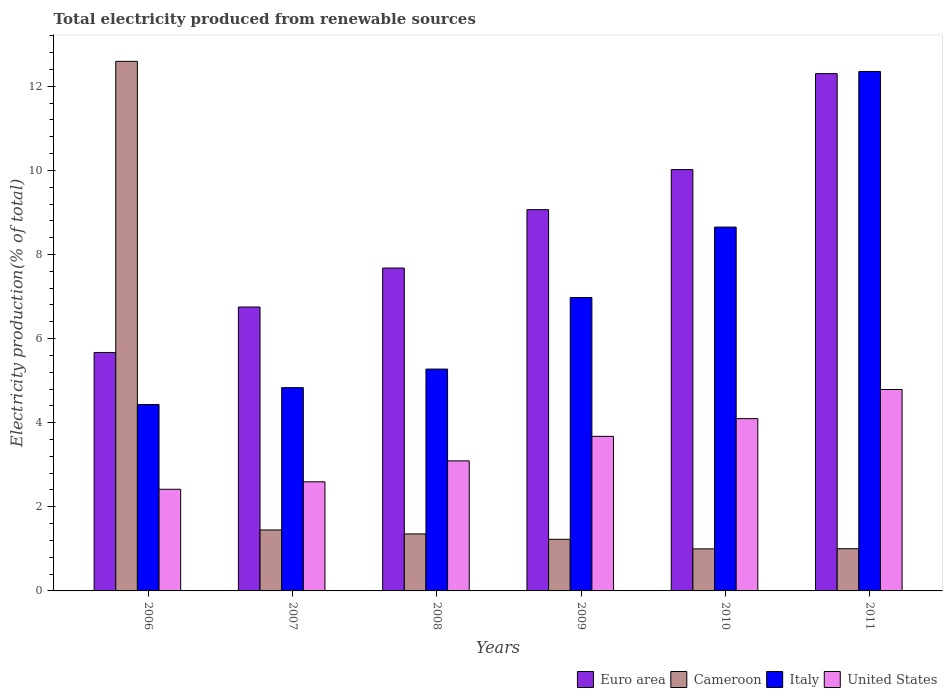How many different coloured bars are there?
Keep it short and to the point. 4. How many bars are there on the 1st tick from the left?
Give a very brief answer. 4. How many bars are there on the 3rd tick from the right?
Give a very brief answer. 4. What is the label of the 4th group of bars from the left?
Your answer should be compact. 2009. What is the total electricity produced in Cameroon in 2006?
Give a very brief answer. 12.59. Across all years, what is the maximum total electricity produced in Italy?
Provide a short and direct response. 12.35. Across all years, what is the minimum total electricity produced in Euro area?
Give a very brief answer. 5.67. What is the total total electricity produced in Cameroon in the graph?
Your answer should be very brief. 18.63. What is the difference between the total electricity produced in Cameroon in 2009 and that in 2011?
Make the answer very short. 0.22. What is the difference between the total electricity produced in Italy in 2009 and the total electricity produced in Cameroon in 2006?
Your answer should be very brief. -5.62. What is the average total electricity produced in United States per year?
Your response must be concise. 3.44. In the year 2009, what is the difference between the total electricity produced in Italy and total electricity produced in Cameroon?
Give a very brief answer. 5.75. In how many years, is the total electricity produced in Euro area greater than 2.4 %?
Provide a succinct answer. 6. What is the ratio of the total electricity produced in Italy in 2007 to that in 2008?
Offer a very short reply. 0.92. Is the total electricity produced in Euro area in 2007 less than that in 2011?
Keep it short and to the point. Yes. Is the difference between the total electricity produced in Italy in 2006 and 2010 greater than the difference between the total electricity produced in Cameroon in 2006 and 2010?
Your answer should be compact. No. What is the difference between the highest and the second highest total electricity produced in Italy?
Ensure brevity in your answer.  3.7. What is the difference between the highest and the lowest total electricity produced in Euro area?
Make the answer very short. 6.63. In how many years, is the total electricity produced in United States greater than the average total electricity produced in United States taken over all years?
Your answer should be very brief. 3. Is the sum of the total electricity produced in Cameroon in 2009 and 2010 greater than the maximum total electricity produced in Euro area across all years?
Your answer should be compact. No. Is it the case that in every year, the sum of the total electricity produced in Cameroon and total electricity produced in Italy is greater than the sum of total electricity produced in United States and total electricity produced in Euro area?
Your answer should be compact. No. What does the 2nd bar from the left in 2009 represents?
Provide a succinct answer. Cameroon. Is it the case that in every year, the sum of the total electricity produced in Euro area and total electricity produced in United States is greater than the total electricity produced in Italy?
Keep it short and to the point. Yes. How many bars are there?
Your answer should be very brief. 24. Are all the bars in the graph horizontal?
Make the answer very short. No. How many years are there in the graph?
Your response must be concise. 6. How are the legend labels stacked?
Give a very brief answer. Horizontal. What is the title of the graph?
Provide a succinct answer. Total electricity produced from renewable sources. What is the Electricity production(% of total) in Euro area in 2006?
Ensure brevity in your answer.  5.67. What is the Electricity production(% of total) of Cameroon in 2006?
Provide a short and direct response. 12.59. What is the Electricity production(% of total) of Italy in 2006?
Your answer should be compact. 4.43. What is the Electricity production(% of total) of United States in 2006?
Provide a succinct answer. 2.42. What is the Electricity production(% of total) of Euro area in 2007?
Give a very brief answer. 6.75. What is the Electricity production(% of total) of Cameroon in 2007?
Provide a succinct answer. 1.45. What is the Electricity production(% of total) in Italy in 2007?
Your answer should be very brief. 4.83. What is the Electricity production(% of total) of United States in 2007?
Give a very brief answer. 2.59. What is the Electricity production(% of total) in Euro area in 2008?
Give a very brief answer. 7.68. What is the Electricity production(% of total) in Cameroon in 2008?
Give a very brief answer. 1.36. What is the Electricity production(% of total) in Italy in 2008?
Keep it short and to the point. 5.28. What is the Electricity production(% of total) of United States in 2008?
Your answer should be compact. 3.09. What is the Electricity production(% of total) of Euro area in 2009?
Offer a terse response. 9.07. What is the Electricity production(% of total) of Cameroon in 2009?
Offer a terse response. 1.23. What is the Electricity production(% of total) of Italy in 2009?
Your answer should be compact. 6.98. What is the Electricity production(% of total) in United States in 2009?
Your response must be concise. 3.68. What is the Electricity production(% of total) in Euro area in 2010?
Your answer should be compact. 10.02. What is the Electricity production(% of total) in Cameroon in 2010?
Provide a succinct answer. 1. What is the Electricity production(% of total) of Italy in 2010?
Make the answer very short. 8.65. What is the Electricity production(% of total) of United States in 2010?
Give a very brief answer. 4.1. What is the Electricity production(% of total) in Euro area in 2011?
Make the answer very short. 12.3. What is the Electricity production(% of total) of Cameroon in 2011?
Provide a succinct answer. 1. What is the Electricity production(% of total) of Italy in 2011?
Keep it short and to the point. 12.35. What is the Electricity production(% of total) in United States in 2011?
Provide a short and direct response. 4.79. Across all years, what is the maximum Electricity production(% of total) in Euro area?
Provide a succinct answer. 12.3. Across all years, what is the maximum Electricity production(% of total) in Cameroon?
Offer a very short reply. 12.59. Across all years, what is the maximum Electricity production(% of total) in Italy?
Give a very brief answer. 12.35. Across all years, what is the maximum Electricity production(% of total) in United States?
Your answer should be very brief. 4.79. Across all years, what is the minimum Electricity production(% of total) of Euro area?
Offer a terse response. 5.67. Across all years, what is the minimum Electricity production(% of total) in Cameroon?
Offer a very short reply. 1. Across all years, what is the minimum Electricity production(% of total) in Italy?
Your answer should be compact. 4.43. Across all years, what is the minimum Electricity production(% of total) in United States?
Make the answer very short. 2.42. What is the total Electricity production(% of total) in Euro area in the graph?
Give a very brief answer. 51.49. What is the total Electricity production(% of total) of Cameroon in the graph?
Give a very brief answer. 18.63. What is the total Electricity production(% of total) in Italy in the graph?
Provide a short and direct response. 42.52. What is the total Electricity production(% of total) of United States in the graph?
Provide a short and direct response. 20.67. What is the difference between the Electricity production(% of total) of Euro area in 2006 and that in 2007?
Offer a terse response. -1.08. What is the difference between the Electricity production(% of total) in Cameroon in 2006 and that in 2007?
Your answer should be compact. 11.14. What is the difference between the Electricity production(% of total) of Italy in 2006 and that in 2007?
Ensure brevity in your answer.  -0.4. What is the difference between the Electricity production(% of total) of United States in 2006 and that in 2007?
Make the answer very short. -0.18. What is the difference between the Electricity production(% of total) of Euro area in 2006 and that in 2008?
Keep it short and to the point. -2.01. What is the difference between the Electricity production(% of total) of Cameroon in 2006 and that in 2008?
Ensure brevity in your answer.  11.24. What is the difference between the Electricity production(% of total) in Italy in 2006 and that in 2008?
Your response must be concise. -0.84. What is the difference between the Electricity production(% of total) of United States in 2006 and that in 2008?
Your answer should be compact. -0.68. What is the difference between the Electricity production(% of total) of Euro area in 2006 and that in 2009?
Your answer should be compact. -3.4. What is the difference between the Electricity production(% of total) of Cameroon in 2006 and that in 2009?
Your response must be concise. 11.37. What is the difference between the Electricity production(% of total) in Italy in 2006 and that in 2009?
Offer a terse response. -2.54. What is the difference between the Electricity production(% of total) of United States in 2006 and that in 2009?
Provide a short and direct response. -1.26. What is the difference between the Electricity production(% of total) in Euro area in 2006 and that in 2010?
Your answer should be compact. -4.35. What is the difference between the Electricity production(% of total) of Cameroon in 2006 and that in 2010?
Make the answer very short. 11.59. What is the difference between the Electricity production(% of total) in Italy in 2006 and that in 2010?
Provide a short and direct response. -4.22. What is the difference between the Electricity production(% of total) in United States in 2006 and that in 2010?
Ensure brevity in your answer.  -1.68. What is the difference between the Electricity production(% of total) of Euro area in 2006 and that in 2011?
Offer a terse response. -6.63. What is the difference between the Electricity production(% of total) in Cameroon in 2006 and that in 2011?
Give a very brief answer. 11.59. What is the difference between the Electricity production(% of total) of Italy in 2006 and that in 2011?
Ensure brevity in your answer.  -7.92. What is the difference between the Electricity production(% of total) in United States in 2006 and that in 2011?
Provide a short and direct response. -2.37. What is the difference between the Electricity production(% of total) in Euro area in 2007 and that in 2008?
Ensure brevity in your answer.  -0.93. What is the difference between the Electricity production(% of total) of Cameroon in 2007 and that in 2008?
Ensure brevity in your answer.  0.09. What is the difference between the Electricity production(% of total) in Italy in 2007 and that in 2008?
Your response must be concise. -0.44. What is the difference between the Electricity production(% of total) of United States in 2007 and that in 2008?
Your answer should be very brief. -0.5. What is the difference between the Electricity production(% of total) in Euro area in 2007 and that in 2009?
Provide a succinct answer. -2.32. What is the difference between the Electricity production(% of total) in Cameroon in 2007 and that in 2009?
Offer a terse response. 0.22. What is the difference between the Electricity production(% of total) in Italy in 2007 and that in 2009?
Offer a very short reply. -2.14. What is the difference between the Electricity production(% of total) in United States in 2007 and that in 2009?
Provide a short and direct response. -1.08. What is the difference between the Electricity production(% of total) of Euro area in 2007 and that in 2010?
Provide a succinct answer. -3.27. What is the difference between the Electricity production(% of total) in Cameroon in 2007 and that in 2010?
Your answer should be compact. 0.45. What is the difference between the Electricity production(% of total) of Italy in 2007 and that in 2010?
Your response must be concise. -3.82. What is the difference between the Electricity production(% of total) in United States in 2007 and that in 2010?
Give a very brief answer. -1.5. What is the difference between the Electricity production(% of total) in Euro area in 2007 and that in 2011?
Your response must be concise. -5.55. What is the difference between the Electricity production(% of total) in Cameroon in 2007 and that in 2011?
Ensure brevity in your answer.  0.45. What is the difference between the Electricity production(% of total) of Italy in 2007 and that in 2011?
Your answer should be compact. -7.52. What is the difference between the Electricity production(% of total) of United States in 2007 and that in 2011?
Your answer should be very brief. -2.19. What is the difference between the Electricity production(% of total) of Euro area in 2008 and that in 2009?
Ensure brevity in your answer.  -1.39. What is the difference between the Electricity production(% of total) of Cameroon in 2008 and that in 2009?
Provide a succinct answer. 0.13. What is the difference between the Electricity production(% of total) in Italy in 2008 and that in 2009?
Your answer should be compact. -1.7. What is the difference between the Electricity production(% of total) in United States in 2008 and that in 2009?
Offer a terse response. -0.58. What is the difference between the Electricity production(% of total) in Euro area in 2008 and that in 2010?
Your answer should be very brief. -2.34. What is the difference between the Electricity production(% of total) in Cameroon in 2008 and that in 2010?
Your answer should be compact. 0.36. What is the difference between the Electricity production(% of total) of Italy in 2008 and that in 2010?
Provide a short and direct response. -3.38. What is the difference between the Electricity production(% of total) in United States in 2008 and that in 2010?
Your answer should be compact. -1. What is the difference between the Electricity production(% of total) in Euro area in 2008 and that in 2011?
Offer a very short reply. -4.62. What is the difference between the Electricity production(% of total) in Cameroon in 2008 and that in 2011?
Provide a succinct answer. 0.35. What is the difference between the Electricity production(% of total) of Italy in 2008 and that in 2011?
Your answer should be compact. -7.08. What is the difference between the Electricity production(% of total) of United States in 2008 and that in 2011?
Provide a succinct answer. -1.7. What is the difference between the Electricity production(% of total) of Euro area in 2009 and that in 2010?
Provide a succinct answer. -0.95. What is the difference between the Electricity production(% of total) in Cameroon in 2009 and that in 2010?
Offer a very short reply. 0.23. What is the difference between the Electricity production(% of total) in Italy in 2009 and that in 2010?
Offer a very short reply. -1.67. What is the difference between the Electricity production(% of total) of United States in 2009 and that in 2010?
Your answer should be compact. -0.42. What is the difference between the Electricity production(% of total) of Euro area in 2009 and that in 2011?
Offer a terse response. -3.23. What is the difference between the Electricity production(% of total) of Cameroon in 2009 and that in 2011?
Ensure brevity in your answer.  0.22. What is the difference between the Electricity production(% of total) in Italy in 2009 and that in 2011?
Offer a very short reply. -5.38. What is the difference between the Electricity production(% of total) in United States in 2009 and that in 2011?
Provide a short and direct response. -1.11. What is the difference between the Electricity production(% of total) of Euro area in 2010 and that in 2011?
Keep it short and to the point. -2.28. What is the difference between the Electricity production(% of total) in Cameroon in 2010 and that in 2011?
Your answer should be very brief. -0. What is the difference between the Electricity production(% of total) in Italy in 2010 and that in 2011?
Provide a short and direct response. -3.7. What is the difference between the Electricity production(% of total) in United States in 2010 and that in 2011?
Provide a short and direct response. -0.69. What is the difference between the Electricity production(% of total) in Euro area in 2006 and the Electricity production(% of total) in Cameroon in 2007?
Your response must be concise. 4.22. What is the difference between the Electricity production(% of total) in Euro area in 2006 and the Electricity production(% of total) in Italy in 2007?
Make the answer very short. 0.84. What is the difference between the Electricity production(% of total) in Euro area in 2006 and the Electricity production(% of total) in United States in 2007?
Offer a terse response. 3.08. What is the difference between the Electricity production(% of total) of Cameroon in 2006 and the Electricity production(% of total) of Italy in 2007?
Provide a succinct answer. 7.76. What is the difference between the Electricity production(% of total) in Cameroon in 2006 and the Electricity production(% of total) in United States in 2007?
Your answer should be very brief. 10. What is the difference between the Electricity production(% of total) in Italy in 2006 and the Electricity production(% of total) in United States in 2007?
Ensure brevity in your answer.  1.84. What is the difference between the Electricity production(% of total) of Euro area in 2006 and the Electricity production(% of total) of Cameroon in 2008?
Your answer should be compact. 4.31. What is the difference between the Electricity production(% of total) in Euro area in 2006 and the Electricity production(% of total) in Italy in 2008?
Provide a short and direct response. 0.39. What is the difference between the Electricity production(% of total) of Euro area in 2006 and the Electricity production(% of total) of United States in 2008?
Offer a very short reply. 2.58. What is the difference between the Electricity production(% of total) in Cameroon in 2006 and the Electricity production(% of total) in Italy in 2008?
Provide a succinct answer. 7.32. What is the difference between the Electricity production(% of total) in Cameroon in 2006 and the Electricity production(% of total) in United States in 2008?
Make the answer very short. 9.5. What is the difference between the Electricity production(% of total) of Italy in 2006 and the Electricity production(% of total) of United States in 2008?
Your answer should be compact. 1.34. What is the difference between the Electricity production(% of total) in Euro area in 2006 and the Electricity production(% of total) in Cameroon in 2009?
Offer a very short reply. 4.44. What is the difference between the Electricity production(% of total) in Euro area in 2006 and the Electricity production(% of total) in Italy in 2009?
Keep it short and to the point. -1.31. What is the difference between the Electricity production(% of total) in Euro area in 2006 and the Electricity production(% of total) in United States in 2009?
Offer a very short reply. 1.99. What is the difference between the Electricity production(% of total) in Cameroon in 2006 and the Electricity production(% of total) in Italy in 2009?
Ensure brevity in your answer.  5.62. What is the difference between the Electricity production(% of total) of Cameroon in 2006 and the Electricity production(% of total) of United States in 2009?
Offer a very short reply. 8.92. What is the difference between the Electricity production(% of total) in Italy in 2006 and the Electricity production(% of total) in United States in 2009?
Give a very brief answer. 0.76. What is the difference between the Electricity production(% of total) in Euro area in 2006 and the Electricity production(% of total) in Cameroon in 2010?
Make the answer very short. 4.67. What is the difference between the Electricity production(% of total) in Euro area in 2006 and the Electricity production(% of total) in Italy in 2010?
Offer a very short reply. -2.98. What is the difference between the Electricity production(% of total) of Euro area in 2006 and the Electricity production(% of total) of United States in 2010?
Provide a short and direct response. 1.57. What is the difference between the Electricity production(% of total) of Cameroon in 2006 and the Electricity production(% of total) of Italy in 2010?
Offer a very short reply. 3.94. What is the difference between the Electricity production(% of total) in Cameroon in 2006 and the Electricity production(% of total) in United States in 2010?
Your answer should be compact. 8.5. What is the difference between the Electricity production(% of total) of Italy in 2006 and the Electricity production(% of total) of United States in 2010?
Your answer should be very brief. 0.34. What is the difference between the Electricity production(% of total) of Euro area in 2006 and the Electricity production(% of total) of Cameroon in 2011?
Offer a very short reply. 4.67. What is the difference between the Electricity production(% of total) in Euro area in 2006 and the Electricity production(% of total) in Italy in 2011?
Make the answer very short. -6.68. What is the difference between the Electricity production(% of total) of Euro area in 2006 and the Electricity production(% of total) of United States in 2011?
Provide a succinct answer. 0.88. What is the difference between the Electricity production(% of total) of Cameroon in 2006 and the Electricity production(% of total) of Italy in 2011?
Offer a very short reply. 0.24. What is the difference between the Electricity production(% of total) in Cameroon in 2006 and the Electricity production(% of total) in United States in 2011?
Offer a terse response. 7.8. What is the difference between the Electricity production(% of total) in Italy in 2006 and the Electricity production(% of total) in United States in 2011?
Ensure brevity in your answer.  -0.36. What is the difference between the Electricity production(% of total) in Euro area in 2007 and the Electricity production(% of total) in Cameroon in 2008?
Your response must be concise. 5.4. What is the difference between the Electricity production(% of total) in Euro area in 2007 and the Electricity production(% of total) in Italy in 2008?
Your response must be concise. 1.48. What is the difference between the Electricity production(% of total) in Euro area in 2007 and the Electricity production(% of total) in United States in 2008?
Offer a terse response. 3.66. What is the difference between the Electricity production(% of total) of Cameroon in 2007 and the Electricity production(% of total) of Italy in 2008?
Give a very brief answer. -3.83. What is the difference between the Electricity production(% of total) of Cameroon in 2007 and the Electricity production(% of total) of United States in 2008?
Offer a very short reply. -1.64. What is the difference between the Electricity production(% of total) of Italy in 2007 and the Electricity production(% of total) of United States in 2008?
Your response must be concise. 1.74. What is the difference between the Electricity production(% of total) of Euro area in 2007 and the Electricity production(% of total) of Cameroon in 2009?
Give a very brief answer. 5.52. What is the difference between the Electricity production(% of total) of Euro area in 2007 and the Electricity production(% of total) of Italy in 2009?
Your response must be concise. -0.23. What is the difference between the Electricity production(% of total) of Euro area in 2007 and the Electricity production(% of total) of United States in 2009?
Offer a very short reply. 3.08. What is the difference between the Electricity production(% of total) of Cameroon in 2007 and the Electricity production(% of total) of Italy in 2009?
Provide a succinct answer. -5.53. What is the difference between the Electricity production(% of total) in Cameroon in 2007 and the Electricity production(% of total) in United States in 2009?
Your response must be concise. -2.23. What is the difference between the Electricity production(% of total) of Italy in 2007 and the Electricity production(% of total) of United States in 2009?
Offer a terse response. 1.16. What is the difference between the Electricity production(% of total) in Euro area in 2007 and the Electricity production(% of total) in Cameroon in 2010?
Your answer should be very brief. 5.75. What is the difference between the Electricity production(% of total) in Euro area in 2007 and the Electricity production(% of total) in Italy in 2010?
Keep it short and to the point. -1.9. What is the difference between the Electricity production(% of total) in Euro area in 2007 and the Electricity production(% of total) in United States in 2010?
Make the answer very short. 2.65. What is the difference between the Electricity production(% of total) in Cameroon in 2007 and the Electricity production(% of total) in Italy in 2010?
Offer a terse response. -7.2. What is the difference between the Electricity production(% of total) of Cameroon in 2007 and the Electricity production(% of total) of United States in 2010?
Offer a terse response. -2.65. What is the difference between the Electricity production(% of total) in Italy in 2007 and the Electricity production(% of total) in United States in 2010?
Keep it short and to the point. 0.74. What is the difference between the Electricity production(% of total) of Euro area in 2007 and the Electricity production(% of total) of Cameroon in 2011?
Keep it short and to the point. 5.75. What is the difference between the Electricity production(% of total) in Euro area in 2007 and the Electricity production(% of total) in Italy in 2011?
Your answer should be compact. -5.6. What is the difference between the Electricity production(% of total) of Euro area in 2007 and the Electricity production(% of total) of United States in 2011?
Ensure brevity in your answer.  1.96. What is the difference between the Electricity production(% of total) of Cameroon in 2007 and the Electricity production(% of total) of Italy in 2011?
Offer a terse response. -10.9. What is the difference between the Electricity production(% of total) in Cameroon in 2007 and the Electricity production(% of total) in United States in 2011?
Provide a short and direct response. -3.34. What is the difference between the Electricity production(% of total) of Italy in 2007 and the Electricity production(% of total) of United States in 2011?
Provide a succinct answer. 0.04. What is the difference between the Electricity production(% of total) in Euro area in 2008 and the Electricity production(% of total) in Cameroon in 2009?
Offer a terse response. 6.45. What is the difference between the Electricity production(% of total) in Euro area in 2008 and the Electricity production(% of total) in Italy in 2009?
Your answer should be compact. 0.7. What is the difference between the Electricity production(% of total) in Euro area in 2008 and the Electricity production(% of total) in United States in 2009?
Offer a very short reply. 4. What is the difference between the Electricity production(% of total) in Cameroon in 2008 and the Electricity production(% of total) in Italy in 2009?
Keep it short and to the point. -5.62. What is the difference between the Electricity production(% of total) in Cameroon in 2008 and the Electricity production(% of total) in United States in 2009?
Provide a short and direct response. -2.32. What is the difference between the Electricity production(% of total) in Italy in 2008 and the Electricity production(% of total) in United States in 2009?
Make the answer very short. 1.6. What is the difference between the Electricity production(% of total) in Euro area in 2008 and the Electricity production(% of total) in Cameroon in 2010?
Offer a terse response. 6.68. What is the difference between the Electricity production(% of total) of Euro area in 2008 and the Electricity production(% of total) of Italy in 2010?
Provide a short and direct response. -0.97. What is the difference between the Electricity production(% of total) in Euro area in 2008 and the Electricity production(% of total) in United States in 2010?
Give a very brief answer. 3.58. What is the difference between the Electricity production(% of total) of Cameroon in 2008 and the Electricity production(% of total) of Italy in 2010?
Make the answer very short. -7.3. What is the difference between the Electricity production(% of total) of Cameroon in 2008 and the Electricity production(% of total) of United States in 2010?
Your response must be concise. -2.74. What is the difference between the Electricity production(% of total) in Italy in 2008 and the Electricity production(% of total) in United States in 2010?
Offer a very short reply. 1.18. What is the difference between the Electricity production(% of total) of Euro area in 2008 and the Electricity production(% of total) of Cameroon in 2011?
Provide a short and direct response. 6.68. What is the difference between the Electricity production(% of total) in Euro area in 2008 and the Electricity production(% of total) in Italy in 2011?
Keep it short and to the point. -4.67. What is the difference between the Electricity production(% of total) of Euro area in 2008 and the Electricity production(% of total) of United States in 2011?
Your answer should be very brief. 2.89. What is the difference between the Electricity production(% of total) in Cameroon in 2008 and the Electricity production(% of total) in Italy in 2011?
Your answer should be compact. -11. What is the difference between the Electricity production(% of total) of Cameroon in 2008 and the Electricity production(% of total) of United States in 2011?
Offer a terse response. -3.43. What is the difference between the Electricity production(% of total) in Italy in 2008 and the Electricity production(% of total) in United States in 2011?
Ensure brevity in your answer.  0.49. What is the difference between the Electricity production(% of total) in Euro area in 2009 and the Electricity production(% of total) in Cameroon in 2010?
Offer a very short reply. 8.07. What is the difference between the Electricity production(% of total) in Euro area in 2009 and the Electricity production(% of total) in Italy in 2010?
Ensure brevity in your answer.  0.41. What is the difference between the Electricity production(% of total) in Euro area in 2009 and the Electricity production(% of total) in United States in 2010?
Make the answer very short. 4.97. What is the difference between the Electricity production(% of total) of Cameroon in 2009 and the Electricity production(% of total) of Italy in 2010?
Ensure brevity in your answer.  -7.42. What is the difference between the Electricity production(% of total) of Cameroon in 2009 and the Electricity production(% of total) of United States in 2010?
Offer a terse response. -2.87. What is the difference between the Electricity production(% of total) in Italy in 2009 and the Electricity production(% of total) in United States in 2010?
Your answer should be very brief. 2.88. What is the difference between the Electricity production(% of total) of Euro area in 2009 and the Electricity production(% of total) of Cameroon in 2011?
Ensure brevity in your answer.  8.06. What is the difference between the Electricity production(% of total) in Euro area in 2009 and the Electricity production(% of total) in Italy in 2011?
Provide a short and direct response. -3.29. What is the difference between the Electricity production(% of total) in Euro area in 2009 and the Electricity production(% of total) in United States in 2011?
Your response must be concise. 4.28. What is the difference between the Electricity production(% of total) of Cameroon in 2009 and the Electricity production(% of total) of Italy in 2011?
Offer a very short reply. -11.13. What is the difference between the Electricity production(% of total) in Cameroon in 2009 and the Electricity production(% of total) in United States in 2011?
Ensure brevity in your answer.  -3.56. What is the difference between the Electricity production(% of total) in Italy in 2009 and the Electricity production(% of total) in United States in 2011?
Your response must be concise. 2.19. What is the difference between the Electricity production(% of total) of Euro area in 2010 and the Electricity production(% of total) of Cameroon in 2011?
Your response must be concise. 9.02. What is the difference between the Electricity production(% of total) of Euro area in 2010 and the Electricity production(% of total) of Italy in 2011?
Your answer should be compact. -2.33. What is the difference between the Electricity production(% of total) of Euro area in 2010 and the Electricity production(% of total) of United States in 2011?
Provide a short and direct response. 5.23. What is the difference between the Electricity production(% of total) in Cameroon in 2010 and the Electricity production(% of total) in Italy in 2011?
Ensure brevity in your answer.  -11.35. What is the difference between the Electricity production(% of total) of Cameroon in 2010 and the Electricity production(% of total) of United States in 2011?
Offer a very short reply. -3.79. What is the difference between the Electricity production(% of total) in Italy in 2010 and the Electricity production(% of total) in United States in 2011?
Provide a short and direct response. 3.86. What is the average Electricity production(% of total) of Euro area per year?
Ensure brevity in your answer.  8.58. What is the average Electricity production(% of total) of Cameroon per year?
Keep it short and to the point. 3.1. What is the average Electricity production(% of total) in Italy per year?
Your answer should be very brief. 7.09. What is the average Electricity production(% of total) in United States per year?
Make the answer very short. 3.44. In the year 2006, what is the difference between the Electricity production(% of total) in Euro area and Electricity production(% of total) in Cameroon?
Offer a terse response. -6.92. In the year 2006, what is the difference between the Electricity production(% of total) of Euro area and Electricity production(% of total) of Italy?
Offer a very short reply. 1.24. In the year 2006, what is the difference between the Electricity production(% of total) in Euro area and Electricity production(% of total) in United States?
Keep it short and to the point. 3.25. In the year 2006, what is the difference between the Electricity production(% of total) of Cameroon and Electricity production(% of total) of Italy?
Provide a succinct answer. 8.16. In the year 2006, what is the difference between the Electricity production(% of total) of Cameroon and Electricity production(% of total) of United States?
Your answer should be very brief. 10.18. In the year 2006, what is the difference between the Electricity production(% of total) in Italy and Electricity production(% of total) in United States?
Keep it short and to the point. 2.02. In the year 2007, what is the difference between the Electricity production(% of total) of Euro area and Electricity production(% of total) of Cameroon?
Your response must be concise. 5.3. In the year 2007, what is the difference between the Electricity production(% of total) of Euro area and Electricity production(% of total) of Italy?
Keep it short and to the point. 1.92. In the year 2007, what is the difference between the Electricity production(% of total) of Euro area and Electricity production(% of total) of United States?
Your answer should be compact. 4.16. In the year 2007, what is the difference between the Electricity production(% of total) of Cameroon and Electricity production(% of total) of Italy?
Offer a very short reply. -3.38. In the year 2007, what is the difference between the Electricity production(% of total) of Cameroon and Electricity production(% of total) of United States?
Offer a terse response. -1.15. In the year 2007, what is the difference between the Electricity production(% of total) in Italy and Electricity production(% of total) in United States?
Make the answer very short. 2.24. In the year 2008, what is the difference between the Electricity production(% of total) in Euro area and Electricity production(% of total) in Cameroon?
Offer a very short reply. 6.32. In the year 2008, what is the difference between the Electricity production(% of total) in Euro area and Electricity production(% of total) in Italy?
Give a very brief answer. 2.4. In the year 2008, what is the difference between the Electricity production(% of total) of Euro area and Electricity production(% of total) of United States?
Make the answer very short. 4.59. In the year 2008, what is the difference between the Electricity production(% of total) of Cameroon and Electricity production(% of total) of Italy?
Make the answer very short. -3.92. In the year 2008, what is the difference between the Electricity production(% of total) in Cameroon and Electricity production(% of total) in United States?
Your answer should be compact. -1.74. In the year 2008, what is the difference between the Electricity production(% of total) of Italy and Electricity production(% of total) of United States?
Ensure brevity in your answer.  2.18. In the year 2009, what is the difference between the Electricity production(% of total) in Euro area and Electricity production(% of total) in Cameroon?
Make the answer very short. 7.84. In the year 2009, what is the difference between the Electricity production(% of total) in Euro area and Electricity production(% of total) in Italy?
Ensure brevity in your answer.  2.09. In the year 2009, what is the difference between the Electricity production(% of total) in Euro area and Electricity production(% of total) in United States?
Offer a terse response. 5.39. In the year 2009, what is the difference between the Electricity production(% of total) of Cameroon and Electricity production(% of total) of Italy?
Ensure brevity in your answer.  -5.75. In the year 2009, what is the difference between the Electricity production(% of total) in Cameroon and Electricity production(% of total) in United States?
Offer a very short reply. -2.45. In the year 2009, what is the difference between the Electricity production(% of total) of Italy and Electricity production(% of total) of United States?
Give a very brief answer. 3.3. In the year 2010, what is the difference between the Electricity production(% of total) of Euro area and Electricity production(% of total) of Cameroon?
Your response must be concise. 9.02. In the year 2010, what is the difference between the Electricity production(% of total) of Euro area and Electricity production(% of total) of Italy?
Ensure brevity in your answer.  1.37. In the year 2010, what is the difference between the Electricity production(% of total) of Euro area and Electricity production(% of total) of United States?
Ensure brevity in your answer.  5.92. In the year 2010, what is the difference between the Electricity production(% of total) in Cameroon and Electricity production(% of total) in Italy?
Offer a terse response. -7.65. In the year 2010, what is the difference between the Electricity production(% of total) of Cameroon and Electricity production(% of total) of United States?
Provide a short and direct response. -3.1. In the year 2010, what is the difference between the Electricity production(% of total) in Italy and Electricity production(% of total) in United States?
Your response must be concise. 4.55. In the year 2011, what is the difference between the Electricity production(% of total) of Euro area and Electricity production(% of total) of Cameroon?
Your answer should be very brief. 11.3. In the year 2011, what is the difference between the Electricity production(% of total) in Euro area and Electricity production(% of total) in Italy?
Provide a short and direct response. -0.05. In the year 2011, what is the difference between the Electricity production(% of total) in Euro area and Electricity production(% of total) in United States?
Your response must be concise. 7.51. In the year 2011, what is the difference between the Electricity production(% of total) in Cameroon and Electricity production(% of total) in Italy?
Offer a terse response. -11.35. In the year 2011, what is the difference between the Electricity production(% of total) in Cameroon and Electricity production(% of total) in United States?
Provide a succinct answer. -3.79. In the year 2011, what is the difference between the Electricity production(% of total) of Italy and Electricity production(% of total) of United States?
Give a very brief answer. 7.56. What is the ratio of the Electricity production(% of total) of Euro area in 2006 to that in 2007?
Give a very brief answer. 0.84. What is the ratio of the Electricity production(% of total) of Cameroon in 2006 to that in 2007?
Your answer should be compact. 8.69. What is the ratio of the Electricity production(% of total) of Italy in 2006 to that in 2007?
Provide a succinct answer. 0.92. What is the ratio of the Electricity production(% of total) in United States in 2006 to that in 2007?
Make the answer very short. 0.93. What is the ratio of the Electricity production(% of total) in Euro area in 2006 to that in 2008?
Make the answer very short. 0.74. What is the ratio of the Electricity production(% of total) of Cameroon in 2006 to that in 2008?
Ensure brevity in your answer.  9.29. What is the ratio of the Electricity production(% of total) in Italy in 2006 to that in 2008?
Give a very brief answer. 0.84. What is the ratio of the Electricity production(% of total) of United States in 2006 to that in 2008?
Offer a very short reply. 0.78. What is the ratio of the Electricity production(% of total) of Euro area in 2006 to that in 2009?
Your answer should be compact. 0.63. What is the ratio of the Electricity production(% of total) in Cameroon in 2006 to that in 2009?
Ensure brevity in your answer.  10.26. What is the ratio of the Electricity production(% of total) of Italy in 2006 to that in 2009?
Ensure brevity in your answer.  0.64. What is the ratio of the Electricity production(% of total) of United States in 2006 to that in 2009?
Your answer should be compact. 0.66. What is the ratio of the Electricity production(% of total) in Euro area in 2006 to that in 2010?
Provide a succinct answer. 0.57. What is the ratio of the Electricity production(% of total) of Cameroon in 2006 to that in 2010?
Provide a succinct answer. 12.59. What is the ratio of the Electricity production(% of total) of Italy in 2006 to that in 2010?
Give a very brief answer. 0.51. What is the ratio of the Electricity production(% of total) in United States in 2006 to that in 2010?
Your answer should be compact. 0.59. What is the ratio of the Electricity production(% of total) in Euro area in 2006 to that in 2011?
Offer a very short reply. 0.46. What is the ratio of the Electricity production(% of total) of Cameroon in 2006 to that in 2011?
Your answer should be compact. 12.55. What is the ratio of the Electricity production(% of total) of Italy in 2006 to that in 2011?
Your answer should be very brief. 0.36. What is the ratio of the Electricity production(% of total) in United States in 2006 to that in 2011?
Your answer should be compact. 0.5. What is the ratio of the Electricity production(% of total) of Euro area in 2007 to that in 2008?
Your answer should be compact. 0.88. What is the ratio of the Electricity production(% of total) in Cameroon in 2007 to that in 2008?
Your answer should be very brief. 1.07. What is the ratio of the Electricity production(% of total) in Italy in 2007 to that in 2008?
Your answer should be compact. 0.92. What is the ratio of the Electricity production(% of total) of United States in 2007 to that in 2008?
Provide a succinct answer. 0.84. What is the ratio of the Electricity production(% of total) of Euro area in 2007 to that in 2009?
Offer a very short reply. 0.74. What is the ratio of the Electricity production(% of total) of Cameroon in 2007 to that in 2009?
Provide a succinct answer. 1.18. What is the ratio of the Electricity production(% of total) of Italy in 2007 to that in 2009?
Keep it short and to the point. 0.69. What is the ratio of the Electricity production(% of total) of United States in 2007 to that in 2009?
Your answer should be very brief. 0.71. What is the ratio of the Electricity production(% of total) of Euro area in 2007 to that in 2010?
Your response must be concise. 0.67. What is the ratio of the Electricity production(% of total) in Cameroon in 2007 to that in 2010?
Give a very brief answer. 1.45. What is the ratio of the Electricity production(% of total) in Italy in 2007 to that in 2010?
Keep it short and to the point. 0.56. What is the ratio of the Electricity production(% of total) in United States in 2007 to that in 2010?
Offer a terse response. 0.63. What is the ratio of the Electricity production(% of total) of Euro area in 2007 to that in 2011?
Make the answer very short. 0.55. What is the ratio of the Electricity production(% of total) of Cameroon in 2007 to that in 2011?
Your answer should be very brief. 1.44. What is the ratio of the Electricity production(% of total) in Italy in 2007 to that in 2011?
Offer a very short reply. 0.39. What is the ratio of the Electricity production(% of total) of United States in 2007 to that in 2011?
Give a very brief answer. 0.54. What is the ratio of the Electricity production(% of total) in Euro area in 2008 to that in 2009?
Ensure brevity in your answer.  0.85. What is the ratio of the Electricity production(% of total) in Cameroon in 2008 to that in 2009?
Offer a very short reply. 1.1. What is the ratio of the Electricity production(% of total) in Italy in 2008 to that in 2009?
Offer a terse response. 0.76. What is the ratio of the Electricity production(% of total) in United States in 2008 to that in 2009?
Offer a very short reply. 0.84. What is the ratio of the Electricity production(% of total) of Euro area in 2008 to that in 2010?
Your answer should be compact. 0.77. What is the ratio of the Electricity production(% of total) in Cameroon in 2008 to that in 2010?
Make the answer very short. 1.36. What is the ratio of the Electricity production(% of total) in Italy in 2008 to that in 2010?
Your answer should be compact. 0.61. What is the ratio of the Electricity production(% of total) in United States in 2008 to that in 2010?
Give a very brief answer. 0.75. What is the ratio of the Electricity production(% of total) of Euro area in 2008 to that in 2011?
Offer a very short reply. 0.62. What is the ratio of the Electricity production(% of total) of Cameroon in 2008 to that in 2011?
Your answer should be compact. 1.35. What is the ratio of the Electricity production(% of total) in Italy in 2008 to that in 2011?
Your answer should be very brief. 0.43. What is the ratio of the Electricity production(% of total) of United States in 2008 to that in 2011?
Your answer should be compact. 0.65. What is the ratio of the Electricity production(% of total) of Euro area in 2009 to that in 2010?
Keep it short and to the point. 0.9. What is the ratio of the Electricity production(% of total) of Cameroon in 2009 to that in 2010?
Ensure brevity in your answer.  1.23. What is the ratio of the Electricity production(% of total) of Italy in 2009 to that in 2010?
Ensure brevity in your answer.  0.81. What is the ratio of the Electricity production(% of total) in United States in 2009 to that in 2010?
Your answer should be very brief. 0.9. What is the ratio of the Electricity production(% of total) in Euro area in 2009 to that in 2011?
Provide a succinct answer. 0.74. What is the ratio of the Electricity production(% of total) in Cameroon in 2009 to that in 2011?
Provide a succinct answer. 1.22. What is the ratio of the Electricity production(% of total) in Italy in 2009 to that in 2011?
Ensure brevity in your answer.  0.56. What is the ratio of the Electricity production(% of total) of United States in 2009 to that in 2011?
Offer a very short reply. 0.77. What is the ratio of the Electricity production(% of total) in Euro area in 2010 to that in 2011?
Your answer should be very brief. 0.81. What is the ratio of the Electricity production(% of total) of Italy in 2010 to that in 2011?
Make the answer very short. 0.7. What is the ratio of the Electricity production(% of total) in United States in 2010 to that in 2011?
Make the answer very short. 0.86. What is the difference between the highest and the second highest Electricity production(% of total) in Euro area?
Give a very brief answer. 2.28. What is the difference between the highest and the second highest Electricity production(% of total) of Cameroon?
Offer a very short reply. 11.14. What is the difference between the highest and the second highest Electricity production(% of total) in Italy?
Provide a succinct answer. 3.7. What is the difference between the highest and the second highest Electricity production(% of total) in United States?
Provide a succinct answer. 0.69. What is the difference between the highest and the lowest Electricity production(% of total) of Euro area?
Make the answer very short. 6.63. What is the difference between the highest and the lowest Electricity production(% of total) in Cameroon?
Make the answer very short. 11.59. What is the difference between the highest and the lowest Electricity production(% of total) in Italy?
Offer a terse response. 7.92. What is the difference between the highest and the lowest Electricity production(% of total) in United States?
Offer a terse response. 2.37. 